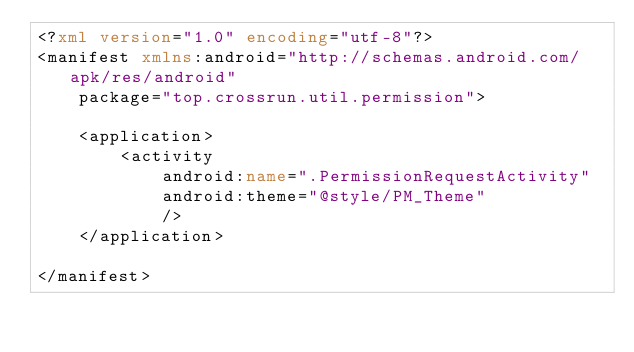<code> <loc_0><loc_0><loc_500><loc_500><_XML_><?xml version="1.0" encoding="utf-8"?>
<manifest xmlns:android="http://schemas.android.com/apk/res/android"
    package="top.crossrun.util.permission">

    <application>
        <activity
            android:name=".PermissionRequestActivity"
            android:theme="@style/PM_Theme"
            />
    </application>

</manifest></code> 